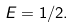Convert formula to latex. <formula><loc_0><loc_0><loc_500><loc_500>E = 1 / 2 .</formula> 